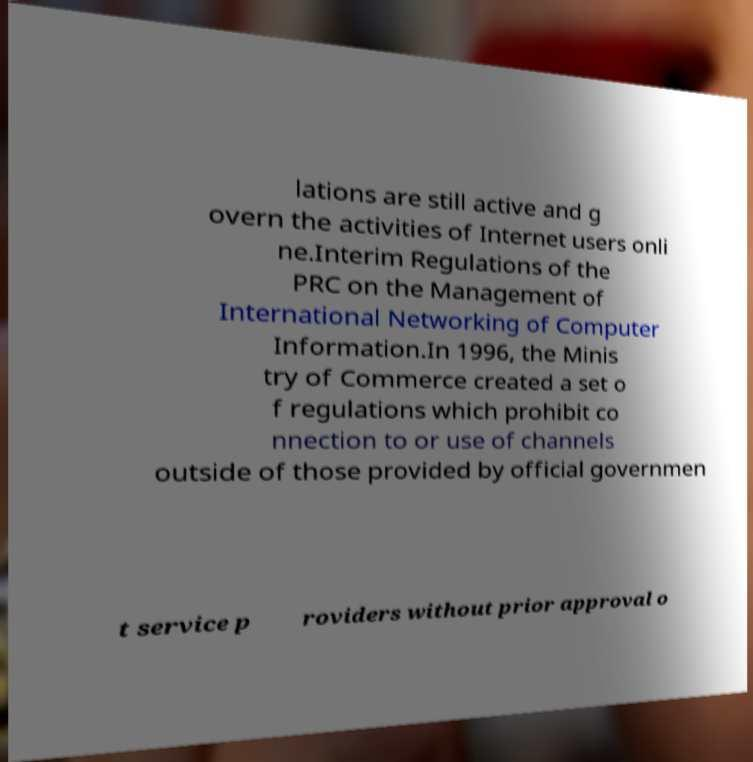Could you assist in decoding the text presented in this image and type it out clearly? lations are still active and g overn the activities of Internet users onli ne.Interim Regulations of the PRC on the Management of International Networking of Computer Information.In 1996, the Minis try of Commerce created a set o f regulations which prohibit co nnection to or use of channels outside of those provided by official governmen t service p roviders without prior approval o 